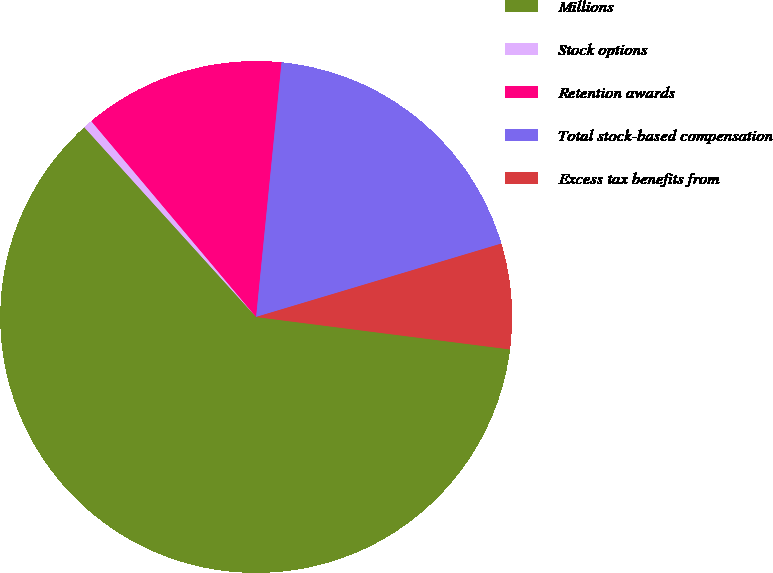Convert chart to OTSL. <chart><loc_0><loc_0><loc_500><loc_500><pie_chart><fcel>Millions<fcel>Stock options<fcel>Retention awards<fcel>Total stock-based compensation<fcel>Excess tax benefits from<nl><fcel>61.27%<fcel>0.58%<fcel>12.72%<fcel>18.79%<fcel>6.65%<nl></chart> 